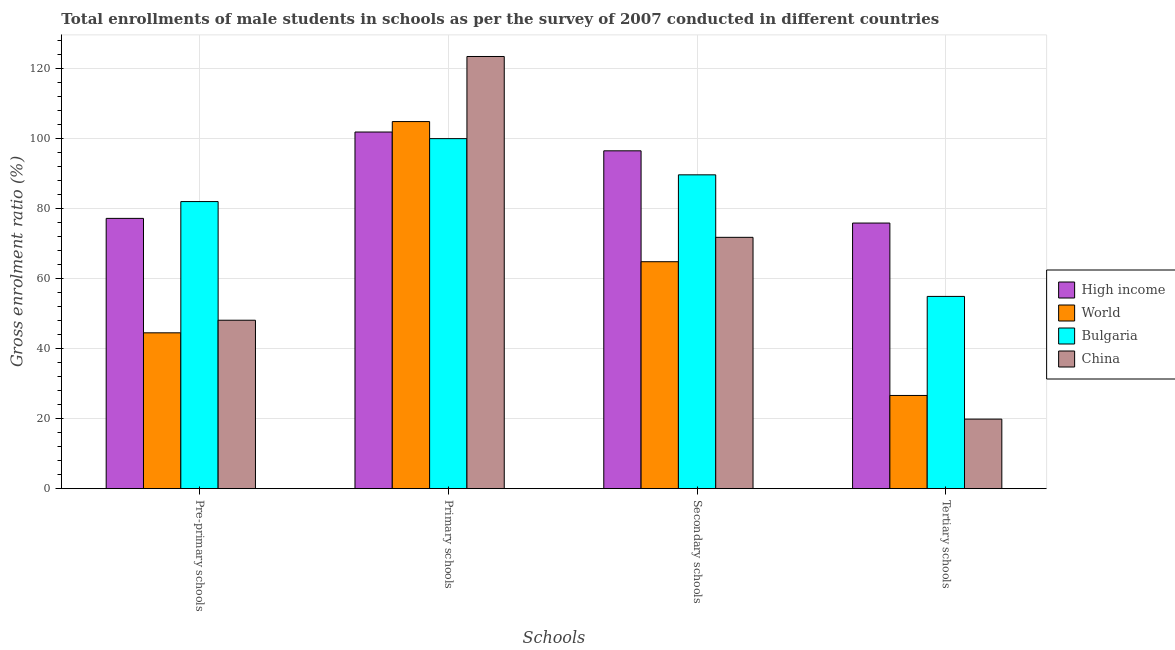How many different coloured bars are there?
Your answer should be very brief. 4. How many groups of bars are there?
Your answer should be compact. 4. How many bars are there on the 4th tick from the left?
Provide a succinct answer. 4. What is the label of the 4th group of bars from the left?
Give a very brief answer. Tertiary schools. What is the gross enrolment ratio(male) in secondary schools in World?
Make the answer very short. 64.88. Across all countries, what is the maximum gross enrolment ratio(male) in primary schools?
Keep it short and to the point. 123.54. Across all countries, what is the minimum gross enrolment ratio(male) in secondary schools?
Ensure brevity in your answer.  64.88. In which country was the gross enrolment ratio(male) in pre-primary schools maximum?
Your answer should be compact. Bulgaria. What is the total gross enrolment ratio(male) in pre-primary schools in the graph?
Offer a very short reply. 252.02. What is the difference between the gross enrolment ratio(male) in tertiary schools in China and that in High income?
Your response must be concise. -56.05. What is the difference between the gross enrolment ratio(male) in pre-primary schools in High income and the gross enrolment ratio(male) in secondary schools in World?
Give a very brief answer. 12.38. What is the average gross enrolment ratio(male) in tertiary schools per country?
Your answer should be compact. 44.35. What is the difference between the gross enrolment ratio(male) in primary schools and gross enrolment ratio(male) in pre-primary schools in China?
Your response must be concise. 75.39. What is the ratio of the gross enrolment ratio(male) in tertiary schools in China to that in High income?
Your response must be concise. 0.26. What is the difference between the highest and the second highest gross enrolment ratio(male) in primary schools?
Provide a short and direct response. 18.61. What is the difference between the highest and the lowest gross enrolment ratio(male) in pre-primary schools?
Your answer should be very brief. 37.51. Is it the case that in every country, the sum of the gross enrolment ratio(male) in pre-primary schools and gross enrolment ratio(male) in primary schools is greater than the sum of gross enrolment ratio(male) in tertiary schools and gross enrolment ratio(male) in secondary schools?
Offer a very short reply. Yes. What does the 2nd bar from the left in Pre-primary schools represents?
Your answer should be very brief. World. How many bars are there?
Make the answer very short. 16. What is the difference between two consecutive major ticks on the Y-axis?
Your answer should be compact. 20. Does the graph contain any zero values?
Your answer should be very brief. No. How are the legend labels stacked?
Your answer should be very brief. Vertical. What is the title of the graph?
Ensure brevity in your answer.  Total enrollments of male students in schools as per the survey of 2007 conducted in different countries. Does "Kenya" appear as one of the legend labels in the graph?
Ensure brevity in your answer.  No. What is the label or title of the X-axis?
Your answer should be compact. Schools. What is the label or title of the Y-axis?
Give a very brief answer. Gross enrolment ratio (%). What is the Gross enrolment ratio (%) of High income in Pre-primary schools?
Offer a terse response. 77.26. What is the Gross enrolment ratio (%) of World in Pre-primary schools?
Your response must be concise. 44.55. What is the Gross enrolment ratio (%) of Bulgaria in Pre-primary schools?
Your response must be concise. 82.06. What is the Gross enrolment ratio (%) of China in Pre-primary schools?
Make the answer very short. 48.15. What is the Gross enrolment ratio (%) of High income in Primary schools?
Provide a succinct answer. 101.95. What is the Gross enrolment ratio (%) in World in Primary schools?
Keep it short and to the point. 104.93. What is the Gross enrolment ratio (%) of Bulgaria in Primary schools?
Provide a short and direct response. 100.06. What is the Gross enrolment ratio (%) of China in Primary schools?
Your answer should be very brief. 123.54. What is the Gross enrolment ratio (%) in High income in Secondary schools?
Ensure brevity in your answer.  96.57. What is the Gross enrolment ratio (%) of World in Secondary schools?
Offer a terse response. 64.88. What is the Gross enrolment ratio (%) of Bulgaria in Secondary schools?
Provide a short and direct response. 89.71. What is the Gross enrolment ratio (%) of China in Secondary schools?
Make the answer very short. 71.84. What is the Gross enrolment ratio (%) of High income in Tertiary schools?
Give a very brief answer. 75.93. What is the Gross enrolment ratio (%) in World in Tertiary schools?
Your answer should be very brief. 26.64. What is the Gross enrolment ratio (%) of Bulgaria in Tertiary schools?
Keep it short and to the point. 54.96. What is the Gross enrolment ratio (%) of China in Tertiary schools?
Your answer should be compact. 19.88. Across all Schools, what is the maximum Gross enrolment ratio (%) of High income?
Offer a terse response. 101.95. Across all Schools, what is the maximum Gross enrolment ratio (%) in World?
Provide a succinct answer. 104.93. Across all Schools, what is the maximum Gross enrolment ratio (%) in Bulgaria?
Give a very brief answer. 100.06. Across all Schools, what is the maximum Gross enrolment ratio (%) of China?
Offer a terse response. 123.54. Across all Schools, what is the minimum Gross enrolment ratio (%) in High income?
Offer a very short reply. 75.93. Across all Schools, what is the minimum Gross enrolment ratio (%) in World?
Your response must be concise. 26.64. Across all Schools, what is the minimum Gross enrolment ratio (%) of Bulgaria?
Keep it short and to the point. 54.96. Across all Schools, what is the minimum Gross enrolment ratio (%) in China?
Keep it short and to the point. 19.88. What is the total Gross enrolment ratio (%) in High income in the graph?
Make the answer very short. 351.71. What is the total Gross enrolment ratio (%) of World in the graph?
Your answer should be compact. 241. What is the total Gross enrolment ratio (%) of Bulgaria in the graph?
Keep it short and to the point. 326.78. What is the total Gross enrolment ratio (%) of China in the graph?
Provide a short and direct response. 263.41. What is the difference between the Gross enrolment ratio (%) in High income in Pre-primary schools and that in Primary schools?
Offer a terse response. -24.68. What is the difference between the Gross enrolment ratio (%) in World in Pre-primary schools and that in Primary schools?
Your answer should be very brief. -60.38. What is the difference between the Gross enrolment ratio (%) of Bulgaria in Pre-primary schools and that in Primary schools?
Make the answer very short. -17.99. What is the difference between the Gross enrolment ratio (%) of China in Pre-primary schools and that in Primary schools?
Give a very brief answer. -75.39. What is the difference between the Gross enrolment ratio (%) of High income in Pre-primary schools and that in Secondary schools?
Provide a short and direct response. -19.31. What is the difference between the Gross enrolment ratio (%) of World in Pre-primary schools and that in Secondary schools?
Provide a succinct answer. -20.33. What is the difference between the Gross enrolment ratio (%) in Bulgaria in Pre-primary schools and that in Secondary schools?
Provide a succinct answer. -7.64. What is the difference between the Gross enrolment ratio (%) in China in Pre-primary schools and that in Secondary schools?
Give a very brief answer. -23.69. What is the difference between the Gross enrolment ratio (%) in High income in Pre-primary schools and that in Tertiary schools?
Provide a succinct answer. 1.33. What is the difference between the Gross enrolment ratio (%) in World in Pre-primary schools and that in Tertiary schools?
Provide a short and direct response. 17.91. What is the difference between the Gross enrolment ratio (%) in Bulgaria in Pre-primary schools and that in Tertiary schools?
Your answer should be compact. 27.11. What is the difference between the Gross enrolment ratio (%) of China in Pre-primary schools and that in Tertiary schools?
Give a very brief answer. 28.27. What is the difference between the Gross enrolment ratio (%) in High income in Primary schools and that in Secondary schools?
Ensure brevity in your answer.  5.37. What is the difference between the Gross enrolment ratio (%) in World in Primary schools and that in Secondary schools?
Provide a short and direct response. 40.05. What is the difference between the Gross enrolment ratio (%) of Bulgaria in Primary schools and that in Secondary schools?
Provide a short and direct response. 10.35. What is the difference between the Gross enrolment ratio (%) of China in Primary schools and that in Secondary schools?
Provide a short and direct response. 51.69. What is the difference between the Gross enrolment ratio (%) of High income in Primary schools and that in Tertiary schools?
Give a very brief answer. 26.02. What is the difference between the Gross enrolment ratio (%) of World in Primary schools and that in Tertiary schools?
Provide a succinct answer. 78.29. What is the difference between the Gross enrolment ratio (%) of Bulgaria in Primary schools and that in Tertiary schools?
Offer a terse response. 45.1. What is the difference between the Gross enrolment ratio (%) in China in Primary schools and that in Tertiary schools?
Provide a short and direct response. 103.66. What is the difference between the Gross enrolment ratio (%) in High income in Secondary schools and that in Tertiary schools?
Keep it short and to the point. 20.65. What is the difference between the Gross enrolment ratio (%) of World in Secondary schools and that in Tertiary schools?
Provide a short and direct response. 38.23. What is the difference between the Gross enrolment ratio (%) of Bulgaria in Secondary schools and that in Tertiary schools?
Keep it short and to the point. 34.75. What is the difference between the Gross enrolment ratio (%) of China in Secondary schools and that in Tertiary schools?
Offer a terse response. 51.96. What is the difference between the Gross enrolment ratio (%) of High income in Pre-primary schools and the Gross enrolment ratio (%) of World in Primary schools?
Your answer should be very brief. -27.67. What is the difference between the Gross enrolment ratio (%) of High income in Pre-primary schools and the Gross enrolment ratio (%) of Bulgaria in Primary schools?
Provide a short and direct response. -22.8. What is the difference between the Gross enrolment ratio (%) of High income in Pre-primary schools and the Gross enrolment ratio (%) of China in Primary schools?
Keep it short and to the point. -46.28. What is the difference between the Gross enrolment ratio (%) of World in Pre-primary schools and the Gross enrolment ratio (%) of Bulgaria in Primary schools?
Make the answer very short. -55.51. What is the difference between the Gross enrolment ratio (%) in World in Pre-primary schools and the Gross enrolment ratio (%) in China in Primary schools?
Your answer should be compact. -78.99. What is the difference between the Gross enrolment ratio (%) in Bulgaria in Pre-primary schools and the Gross enrolment ratio (%) in China in Primary schools?
Provide a succinct answer. -41.47. What is the difference between the Gross enrolment ratio (%) in High income in Pre-primary schools and the Gross enrolment ratio (%) in World in Secondary schools?
Your answer should be compact. 12.38. What is the difference between the Gross enrolment ratio (%) in High income in Pre-primary schools and the Gross enrolment ratio (%) in Bulgaria in Secondary schools?
Make the answer very short. -12.45. What is the difference between the Gross enrolment ratio (%) in High income in Pre-primary schools and the Gross enrolment ratio (%) in China in Secondary schools?
Make the answer very short. 5.42. What is the difference between the Gross enrolment ratio (%) of World in Pre-primary schools and the Gross enrolment ratio (%) of Bulgaria in Secondary schools?
Your response must be concise. -45.16. What is the difference between the Gross enrolment ratio (%) of World in Pre-primary schools and the Gross enrolment ratio (%) of China in Secondary schools?
Offer a very short reply. -27.29. What is the difference between the Gross enrolment ratio (%) of Bulgaria in Pre-primary schools and the Gross enrolment ratio (%) of China in Secondary schools?
Make the answer very short. 10.22. What is the difference between the Gross enrolment ratio (%) in High income in Pre-primary schools and the Gross enrolment ratio (%) in World in Tertiary schools?
Make the answer very short. 50.62. What is the difference between the Gross enrolment ratio (%) of High income in Pre-primary schools and the Gross enrolment ratio (%) of Bulgaria in Tertiary schools?
Your answer should be compact. 22.31. What is the difference between the Gross enrolment ratio (%) of High income in Pre-primary schools and the Gross enrolment ratio (%) of China in Tertiary schools?
Offer a terse response. 57.38. What is the difference between the Gross enrolment ratio (%) in World in Pre-primary schools and the Gross enrolment ratio (%) in Bulgaria in Tertiary schools?
Ensure brevity in your answer.  -10.41. What is the difference between the Gross enrolment ratio (%) of World in Pre-primary schools and the Gross enrolment ratio (%) of China in Tertiary schools?
Give a very brief answer. 24.67. What is the difference between the Gross enrolment ratio (%) in Bulgaria in Pre-primary schools and the Gross enrolment ratio (%) in China in Tertiary schools?
Your answer should be compact. 62.18. What is the difference between the Gross enrolment ratio (%) in High income in Primary schools and the Gross enrolment ratio (%) in World in Secondary schools?
Your answer should be compact. 37.07. What is the difference between the Gross enrolment ratio (%) in High income in Primary schools and the Gross enrolment ratio (%) in Bulgaria in Secondary schools?
Your answer should be very brief. 12.24. What is the difference between the Gross enrolment ratio (%) of High income in Primary schools and the Gross enrolment ratio (%) of China in Secondary schools?
Your answer should be compact. 30.1. What is the difference between the Gross enrolment ratio (%) of World in Primary schools and the Gross enrolment ratio (%) of Bulgaria in Secondary schools?
Provide a succinct answer. 15.22. What is the difference between the Gross enrolment ratio (%) in World in Primary schools and the Gross enrolment ratio (%) in China in Secondary schools?
Offer a terse response. 33.09. What is the difference between the Gross enrolment ratio (%) in Bulgaria in Primary schools and the Gross enrolment ratio (%) in China in Secondary schools?
Make the answer very short. 28.21. What is the difference between the Gross enrolment ratio (%) in High income in Primary schools and the Gross enrolment ratio (%) in World in Tertiary schools?
Provide a short and direct response. 75.3. What is the difference between the Gross enrolment ratio (%) in High income in Primary schools and the Gross enrolment ratio (%) in Bulgaria in Tertiary schools?
Offer a very short reply. 46.99. What is the difference between the Gross enrolment ratio (%) in High income in Primary schools and the Gross enrolment ratio (%) in China in Tertiary schools?
Give a very brief answer. 82.07. What is the difference between the Gross enrolment ratio (%) in World in Primary schools and the Gross enrolment ratio (%) in Bulgaria in Tertiary schools?
Your response must be concise. 49.98. What is the difference between the Gross enrolment ratio (%) of World in Primary schools and the Gross enrolment ratio (%) of China in Tertiary schools?
Offer a terse response. 85.05. What is the difference between the Gross enrolment ratio (%) of Bulgaria in Primary schools and the Gross enrolment ratio (%) of China in Tertiary schools?
Keep it short and to the point. 80.18. What is the difference between the Gross enrolment ratio (%) in High income in Secondary schools and the Gross enrolment ratio (%) in World in Tertiary schools?
Offer a very short reply. 69.93. What is the difference between the Gross enrolment ratio (%) of High income in Secondary schools and the Gross enrolment ratio (%) of Bulgaria in Tertiary schools?
Ensure brevity in your answer.  41.62. What is the difference between the Gross enrolment ratio (%) of High income in Secondary schools and the Gross enrolment ratio (%) of China in Tertiary schools?
Give a very brief answer. 76.69. What is the difference between the Gross enrolment ratio (%) in World in Secondary schools and the Gross enrolment ratio (%) in Bulgaria in Tertiary schools?
Offer a very short reply. 9.92. What is the difference between the Gross enrolment ratio (%) in World in Secondary schools and the Gross enrolment ratio (%) in China in Tertiary schools?
Offer a very short reply. 45. What is the difference between the Gross enrolment ratio (%) of Bulgaria in Secondary schools and the Gross enrolment ratio (%) of China in Tertiary schools?
Offer a terse response. 69.83. What is the average Gross enrolment ratio (%) in High income per Schools?
Keep it short and to the point. 87.93. What is the average Gross enrolment ratio (%) in World per Schools?
Your response must be concise. 60.25. What is the average Gross enrolment ratio (%) of Bulgaria per Schools?
Your answer should be compact. 81.7. What is the average Gross enrolment ratio (%) of China per Schools?
Your answer should be compact. 65.85. What is the difference between the Gross enrolment ratio (%) in High income and Gross enrolment ratio (%) in World in Pre-primary schools?
Your answer should be very brief. 32.71. What is the difference between the Gross enrolment ratio (%) of High income and Gross enrolment ratio (%) of Bulgaria in Pre-primary schools?
Your response must be concise. -4.8. What is the difference between the Gross enrolment ratio (%) of High income and Gross enrolment ratio (%) of China in Pre-primary schools?
Make the answer very short. 29.11. What is the difference between the Gross enrolment ratio (%) of World and Gross enrolment ratio (%) of Bulgaria in Pre-primary schools?
Ensure brevity in your answer.  -37.51. What is the difference between the Gross enrolment ratio (%) of World and Gross enrolment ratio (%) of China in Pre-primary schools?
Ensure brevity in your answer.  -3.6. What is the difference between the Gross enrolment ratio (%) in Bulgaria and Gross enrolment ratio (%) in China in Pre-primary schools?
Make the answer very short. 33.92. What is the difference between the Gross enrolment ratio (%) in High income and Gross enrolment ratio (%) in World in Primary schools?
Your answer should be very brief. -2.99. What is the difference between the Gross enrolment ratio (%) of High income and Gross enrolment ratio (%) of Bulgaria in Primary schools?
Make the answer very short. 1.89. What is the difference between the Gross enrolment ratio (%) of High income and Gross enrolment ratio (%) of China in Primary schools?
Offer a very short reply. -21.59. What is the difference between the Gross enrolment ratio (%) of World and Gross enrolment ratio (%) of Bulgaria in Primary schools?
Ensure brevity in your answer.  4.87. What is the difference between the Gross enrolment ratio (%) of World and Gross enrolment ratio (%) of China in Primary schools?
Make the answer very short. -18.61. What is the difference between the Gross enrolment ratio (%) in Bulgaria and Gross enrolment ratio (%) in China in Primary schools?
Offer a very short reply. -23.48. What is the difference between the Gross enrolment ratio (%) of High income and Gross enrolment ratio (%) of World in Secondary schools?
Give a very brief answer. 31.7. What is the difference between the Gross enrolment ratio (%) of High income and Gross enrolment ratio (%) of Bulgaria in Secondary schools?
Your response must be concise. 6.87. What is the difference between the Gross enrolment ratio (%) in High income and Gross enrolment ratio (%) in China in Secondary schools?
Your response must be concise. 24.73. What is the difference between the Gross enrolment ratio (%) of World and Gross enrolment ratio (%) of Bulgaria in Secondary schools?
Your response must be concise. -24.83. What is the difference between the Gross enrolment ratio (%) in World and Gross enrolment ratio (%) in China in Secondary schools?
Ensure brevity in your answer.  -6.97. What is the difference between the Gross enrolment ratio (%) of Bulgaria and Gross enrolment ratio (%) of China in Secondary schools?
Ensure brevity in your answer.  17.86. What is the difference between the Gross enrolment ratio (%) in High income and Gross enrolment ratio (%) in World in Tertiary schools?
Provide a short and direct response. 49.28. What is the difference between the Gross enrolment ratio (%) of High income and Gross enrolment ratio (%) of Bulgaria in Tertiary schools?
Ensure brevity in your answer.  20.97. What is the difference between the Gross enrolment ratio (%) of High income and Gross enrolment ratio (%) of China in Tertiary schools?
Your answer should be compact. 56.05. What is the difference between the Gross enrolment ratio (%) in World and Gross enrolment ratio (%) in Bulgaria in Tertiary schools?
Your answer should be compact. -28.31. What is the difference between the Gross enrolment ratio (%) in World and Gross enrolment ratio (%) in China in Tertiary schools?
Offer a very short reply. 6.76. What is the difference between the Gross enrolment ratio (%) of Bulgaria and Gross enrolment ratio (%) of China in Tertiary schools?
Your answer should be compact. 35.08. What is the ratio of the Gross enrolment ratio (%) in High income in Pre-primary schools to that in Primary schools?
Give a very brief answer. 0.76. What is the ratio of the Gross enrolment ratio (%) of World in Pre-primary schools to that in Primary schools?
Your response must be concise. 0.42. What is the ratio of the Gross enrolment ratio (%) of Bulgaria in Pre-primary schools to that in Primary schools?
Your response must be concise. 0.82. What is the ratio of the Gross enrolment ratio (%) of China in Pre-primary schools to that in Primary schools?
Your answer should be very brief. 0.39. What is the ratio of the Gross enrolment ratio (%) of World in Pre-primary schools to that in Secondary schools?
Keep it short and to the point. 0.69. What is the ratio of the Gross enrolment ratio (%) in Bulgaria in Pre-primary schools to that in Secondary schools?
Keep it short and to the point. 0.91. What is the ratio of the Gross enrolment ratio (%) in China in Pre-primary schools to that in Secondary schools?
Keep it short and to the point. 0.67. What is the ratio of the Gross enrolment ratio (%) of High income in Pre-primary schools to that in Tertiary schools?
Provide a short and direct response. 1.02. What is the ratio of the Gross enrolment ratio (%) in World in Pre-primary schools to that in Tertiary schools?
Provide a short and direct response. 1.67. What is the ratio of the Gross enrolment ratio (%) in Bulgaria in Pre-primary schools to that in Tertiary schools?
Your response must be concise. 1.49. What is the ratio of the Gross enrolment ratio (%) in China in Pre-primary schools to that in Tertiary schools?
Offer a terse response. 2.42. What is the ratio of the Gross enrolment ratio (%) in High income in Primary schools to that in Secondary schools?
Your response must be concise. 1.06. What is the ratio of the Gross enrolment ratio (%) of World in Primary schools to that in Secondary schools?
Your answer should be compact. 1.62. What is the ratio of the Gross enrolment ratio (%) of Bulgaria in Primary schools to that in Secondary schools?
Your response must be concise. 1.12. What is the ratio of the Gross enrolment ratio (%) of China in Primary schools to that in Secondary schools?
Your answer should be compact. 1.72. What is the ratio of the Gross enrolment ratio (%) of High income in Primary schools to that in Tertiary schools?
Provide a succinct answer. 1.34. What is the ratio of the Gross enrolment ratio (%) of World in Primary schools to that in Tertiary schools?
Keep it short and to the point. 3.94. What is the ratio of the Gross enrolment ratio (%) in Bulgaria in Primary schools to that in Tertiary schools?
Offer a terse response. 1.82. What is the ratio of the Gross enrolment ratio (%) of China in Primary schools to that in Tertiary schools?
Make the answer very short. 6.21. What is the ratio of the Gross enrolment ratio (%) of High income in Secondary schools to that in Tertiary schools?
Your response must be concise. 1.27. What is the ratio of the Gross enrolment ratio (%) in World in Secondary schools to that in Tertiary schools?
Ensure brevity in your answer.  2.43. What is the ratio of the Gross enrolment ratio (%) of Bulgaria in Secondary schools to that in Tertiary schools?
Your response must be concise. 1.63. What is the ratio of the Gross enrolment ratio (%) in China in Secondary schools to that in Tertiary schools?
Make the answer very short. 3.61. What is the difference between the highest and the second highest Gross enrolment ratio (%) in High income?
Offer a very short reply. 5.37. What is the difference between the highest and the second highest Gross enrolment ratio (%) in World?
Provide a short and direct response. 40.05. What is the difference between the highest and the second highest Gross enrolment ratio (%) in Bulgaria?
Provide a short and direct response. 10.35. What is the difference between the highest and the second highest Gross enrolment ratio (%) of China?
Provide a short and direct response. 51.69. What is the difference between the highest and the lowest Gross enrolment ratio (%) of High income?
Give a very brief answer. 26.02. What is the difference between the highest and the lowest Gross enrolment ratio (%) of World?
Your answer should be compact. 78.29. What is the difference between the highest and the lowest Gross enrolment ratio (%) in Bulgaria?
Offer a terse response. 45.1. What is the difference between the highest and the lowest Gross enrolment ratio (%) in China?
Offer a very short reply. 103.66. 